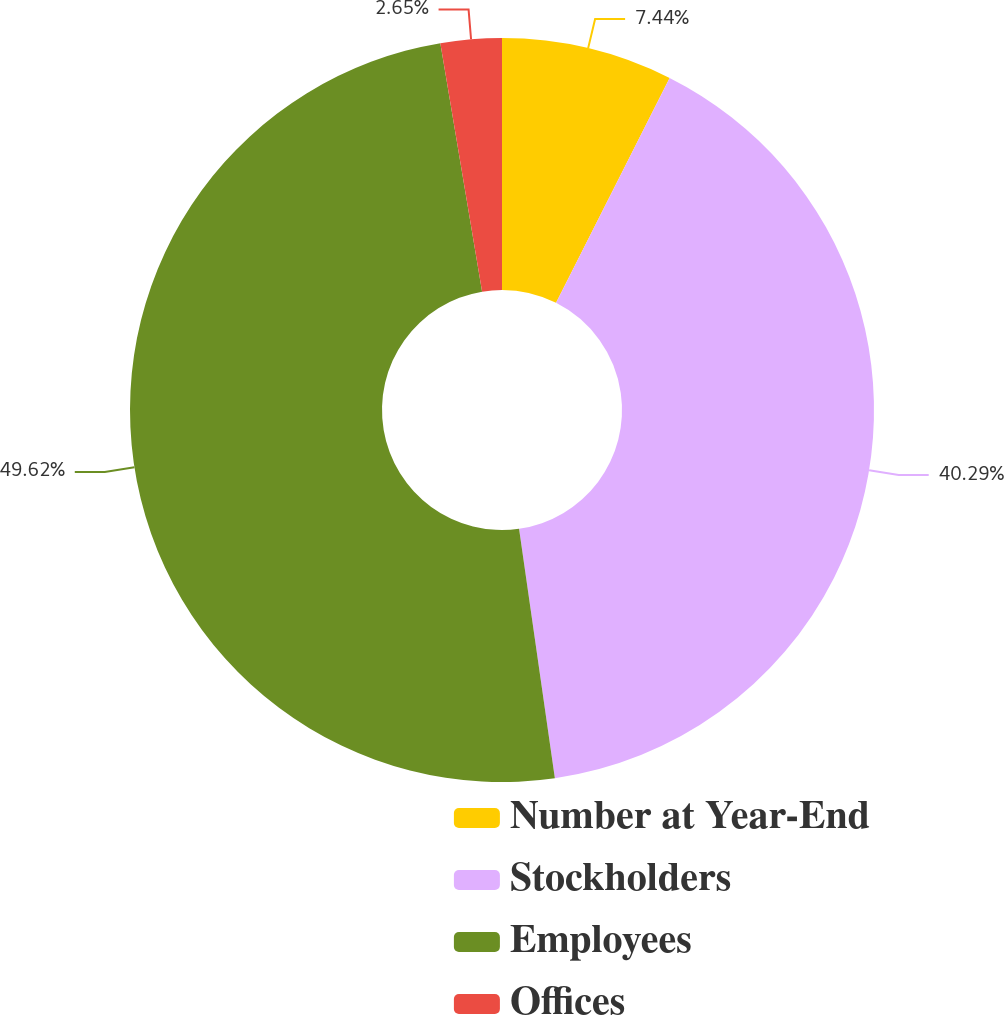<chart> <loc_0><loc_0><loc_500><loc_500><pie_chart><fcel>Number at Year-End<fcel>Stockholders<fcel>Employees<fcel>Offices<nl><fcel>7.44%<fcel>40.29%<fcel>49.62%<fcel>2.65%<nl></chart> 